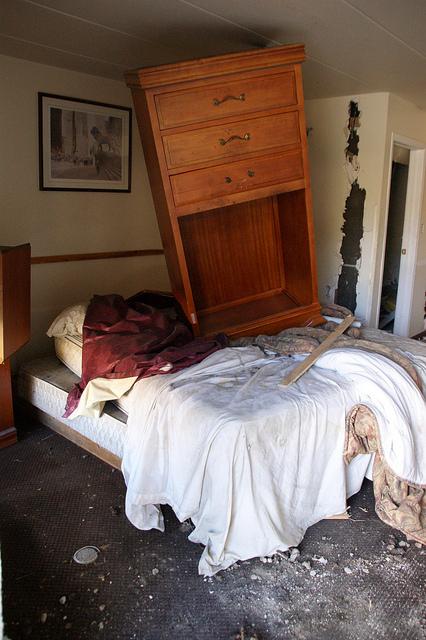What is on top of the bed?
Concise answer only. Dresser. Is the room a mess?
Keep it brief. Yes. How many people use this bed?
Keep it brief. 2. Would you want to sleep in this bed?
Answer briefly. No. 